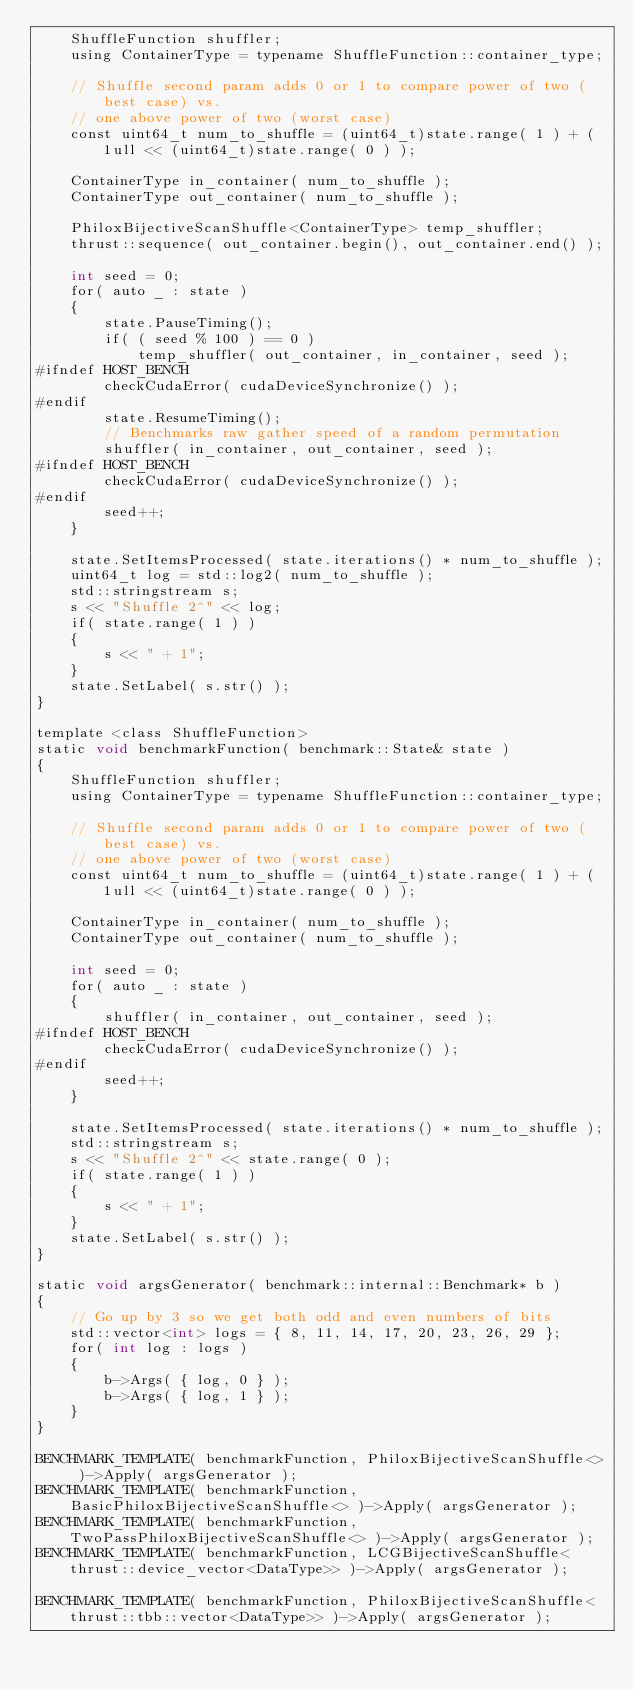Convert code to text. <code><loc_0><loc_0><loc_500><loc_500><_Cuda_>    ShuffleFunction shuffler;
    using ContainerType = typename ShuffleFunction::container_type;

    // Shuffle second param adds 0 or 1 to compare power of two (best case) vs.
    // one above power of two (worst case)
    const uint64_t num_to_shuffle = (uint64_t)state.range( 1 ) + ( 1ull << (uint64_t)state.range( 0 ) );

    ContainerType in_container( num_to_shuffle );
    ContainerType out_container( num_to_shuffle );

    PhiloxBijectiveScanShuffle<ContainerType> temp_shuffler;
    thrust::sequence( out_container.begin(), out_container.end() );

    int seed = 0;
    for( auto _ : state )
    {
        state.PauseTiming();
        if( ( seed % 100 ) == 0 )
            temp_shuffler( out_container, in_container, seed );
#ifndef HOST_BENCH
        checkCudaError( cudaDeviceSynchronize() );
#endif
        state.ResumeTiming();
        // Benchmarks raw gather speed of a random permutation
        shuffler( in_container, out_container, seed );
#ifndef HOST_BENCH
        checkCudaError( cudaDeviceSynchronize() );
#endif
        seed++;
    }

    state.SetItemsProcessed( state.iterations() * num_to_shuffle );
    uint64_t log = std::log2( num_to_shuffle );
    std::stringstream s;
    s << "Shuffle 2^" << log;
    if( state.range( 1 ) )
    {
        s << " + 1";
    }
    state.SetLabel( s.str() );
}

template <class ShuffleFunction>
static void benchmarkFunction( benchmark::State& state )
{
    ShuffleFunction shuffler;
    using ContainerType = typename ShuffleFunction::container_type;

    // Shuffle second param adds 0 or 1 to compare power of two (best case) vs.
    // one above power of two (worst case)
    const uint64_t num_to_shuffle = (uint64_t)state.range( 1 ) + ( 1ull << (uint64_t)state.range( 0 ) );

    ContainerType in_container( num_to_shuffle );
    ContainerType out_container( num_to_shuffle );

    int seed = 0;
    for( auto _ : state )
    {
        shuffler( in_container, out_container, seed );
#ifndef HOST_BENCH
        checkCudaError( cudaDeviceSynchronize() );
#endif
        seed++;
    }

    state.SetItemsProcessed( state.iterations() * num_to_shuffle );
    std::stringstream s;
    s << "Shuffle 2^" << state.range( 0 );
    if( state.range( 1 ) )
    {
        s << " + 1";
    }
    state.SetLabel( s.str() );
}

static void argsGenerator( benchmark::internal::Benchmark* b )
{
    // Go up by 3 so we get both odd and even numbers of bits
    std::vector<int> logs = { 8, 11, 14, 17, 20, 23, 26, 29 };
    for( int log : logs )
    {
        b->Args( { log, 0 } );
        b->Args( { log, 1 } );
    }
}

BENCHMARK_TEMPLATE( benchmarkFunction, PhiloxBijectiveScanShuffle<> )->Apply( argsGenerator );
BENCHMARK_TEMPLATE( benchmarkFunction, BasicPhiloxBijectiveScanShuffle<> )->Apply( argsGenerator );
BENCHMARK_TEMPLATE( benchmarkFunction, TwoPassPhiloxBijectiveScanShuffle<> )->Apply( argsGenerator );
BENCHMARK_TEMPLATE( benchmarkFunction, LCGBijectiveScanShuffle<thrust::device_vector<DataType>> )->Apply( argsGenerator );

BENCHMARK_TEMPLATE( benchmarkFunction, PhiloxBijectiveScanShuffle<thrust::tbb::vector<DataType>> )->Apply( argsGenerator );
</code> 